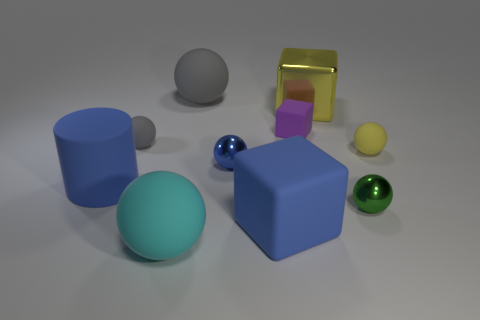Subtract all red cylinders. How many gray spheres are left? 2 Subtract all yellow spheres. How many spheres are left? 5 Subtract all blue spheres. How many spheres are left? 5 Subtract 3 spheres. How many spheres are left? 3 Subtract all green spheres. Subtract all green cubes. How many spheres are left? 5 Subtract all spheres. How many objects are left? 4 Subtract all gray rubber things. Subtract all yellow balls. How many objects are left? 7 Add 8 blue matte objects. How many blue matte objects are left? 10 Add 7 large purple objects. How many large purple objects exist? 7 Subtract 1 yellow balls. How many objects are left? 9 